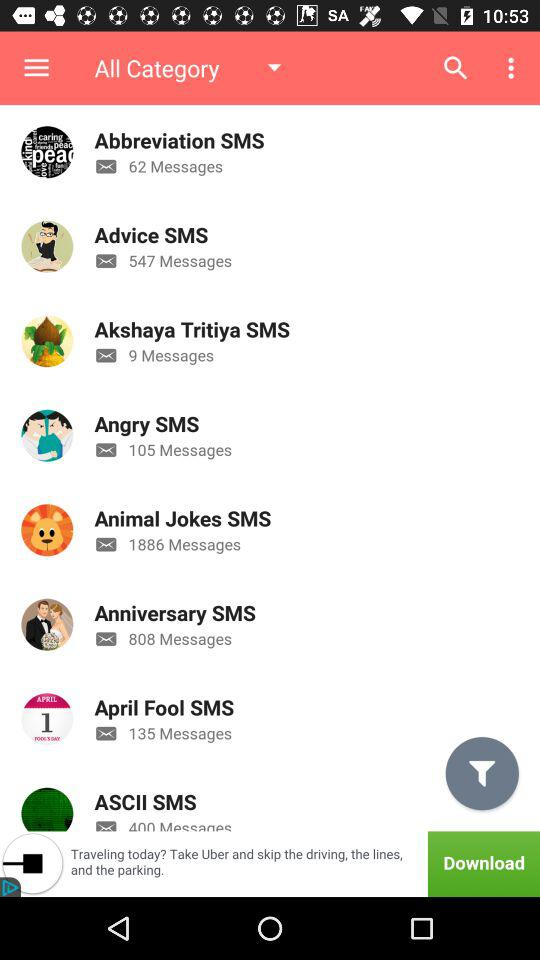How many messages are there in the category 'Abbreviation SMS'?
Answer the question using a single word or phrase. 62 